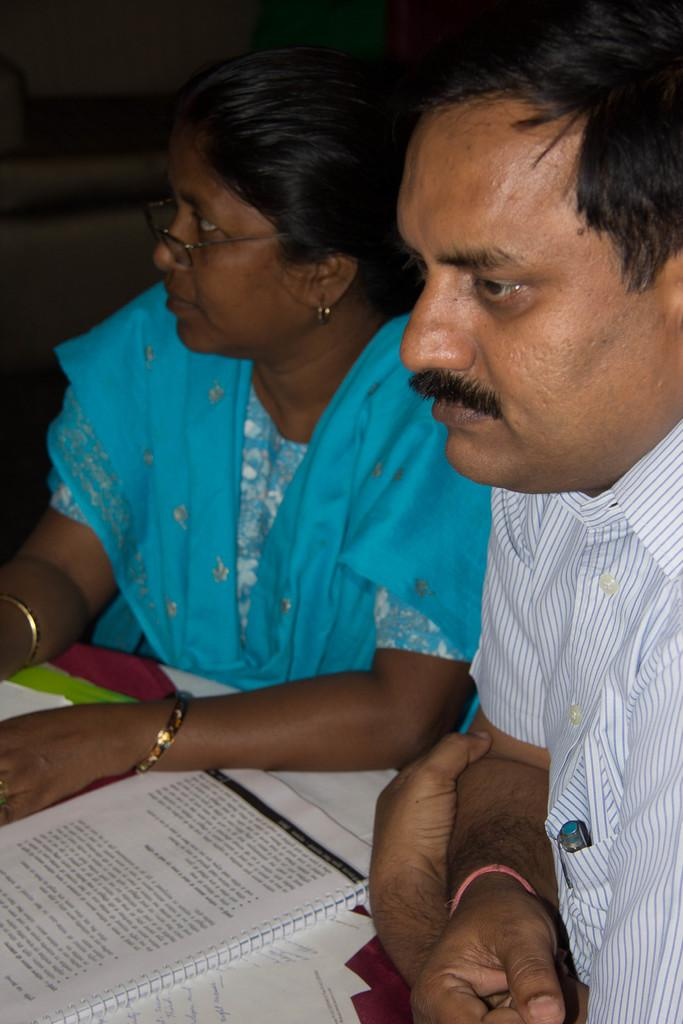How many people are present in the image? There are two persons sitting in the image. What objects can be seen on the table in the image? There are books on a table in the image. Can you describe the lighting in the image? The setting is dark. What type of insurance policy is being discussed by the ladybug in the image? There is no ladybug present in the image, and therefore no discussion about insurance policies. 